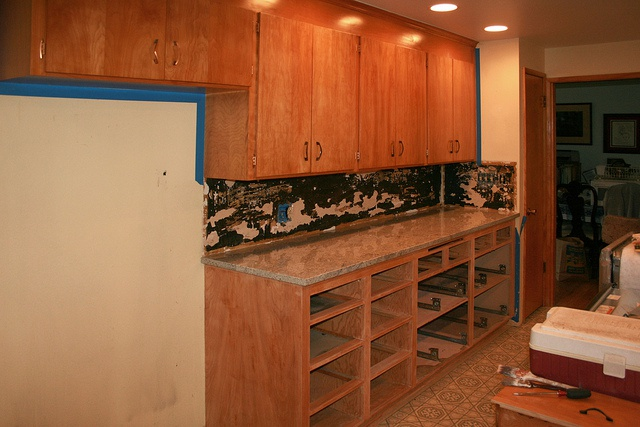Describe the objects in this image and their specific colors. I can see refrigerator in black and tan tones and chair in black tones in this image. 